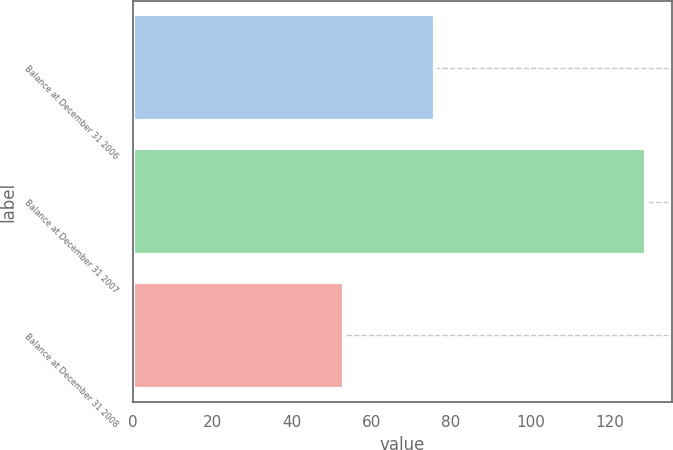Convert chart to OTSL. <chart><loc_0><loc_0><loc_500><loc_500><bar_chart><fcel>Balance at December 31 2006<fcel>Balance at December 31 2007<fcel>Balance at December 31 2008<nl><fcel>76<fcel>129<fcel>53<nl></chart> 